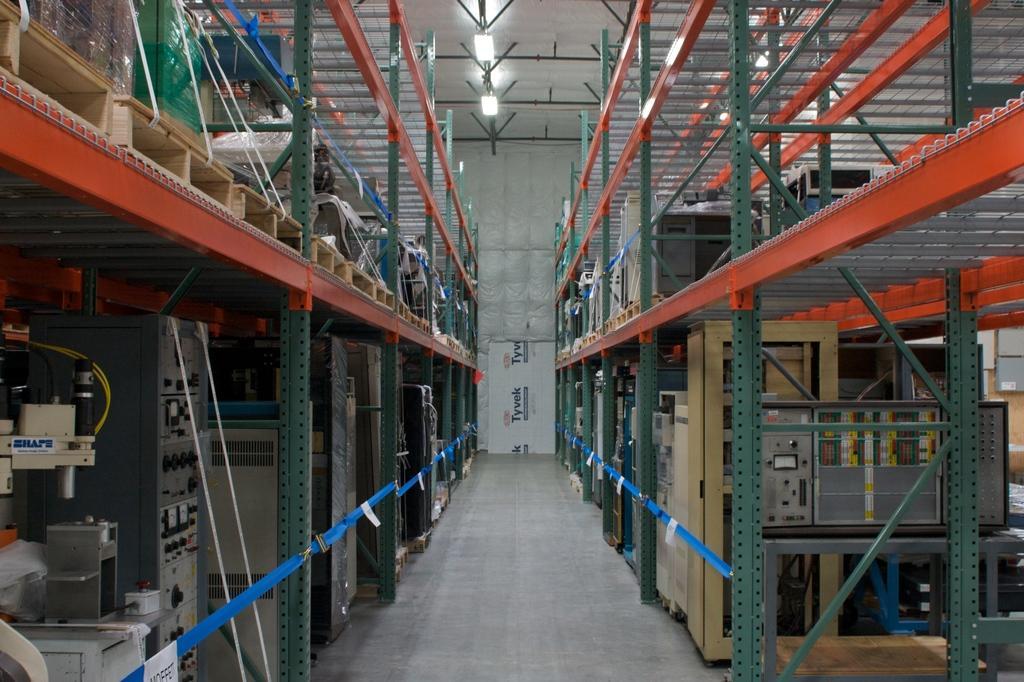Describe this image in one or two sentences. In this picture we can see few machines, metal rods and other things, in the background we can find lights. 